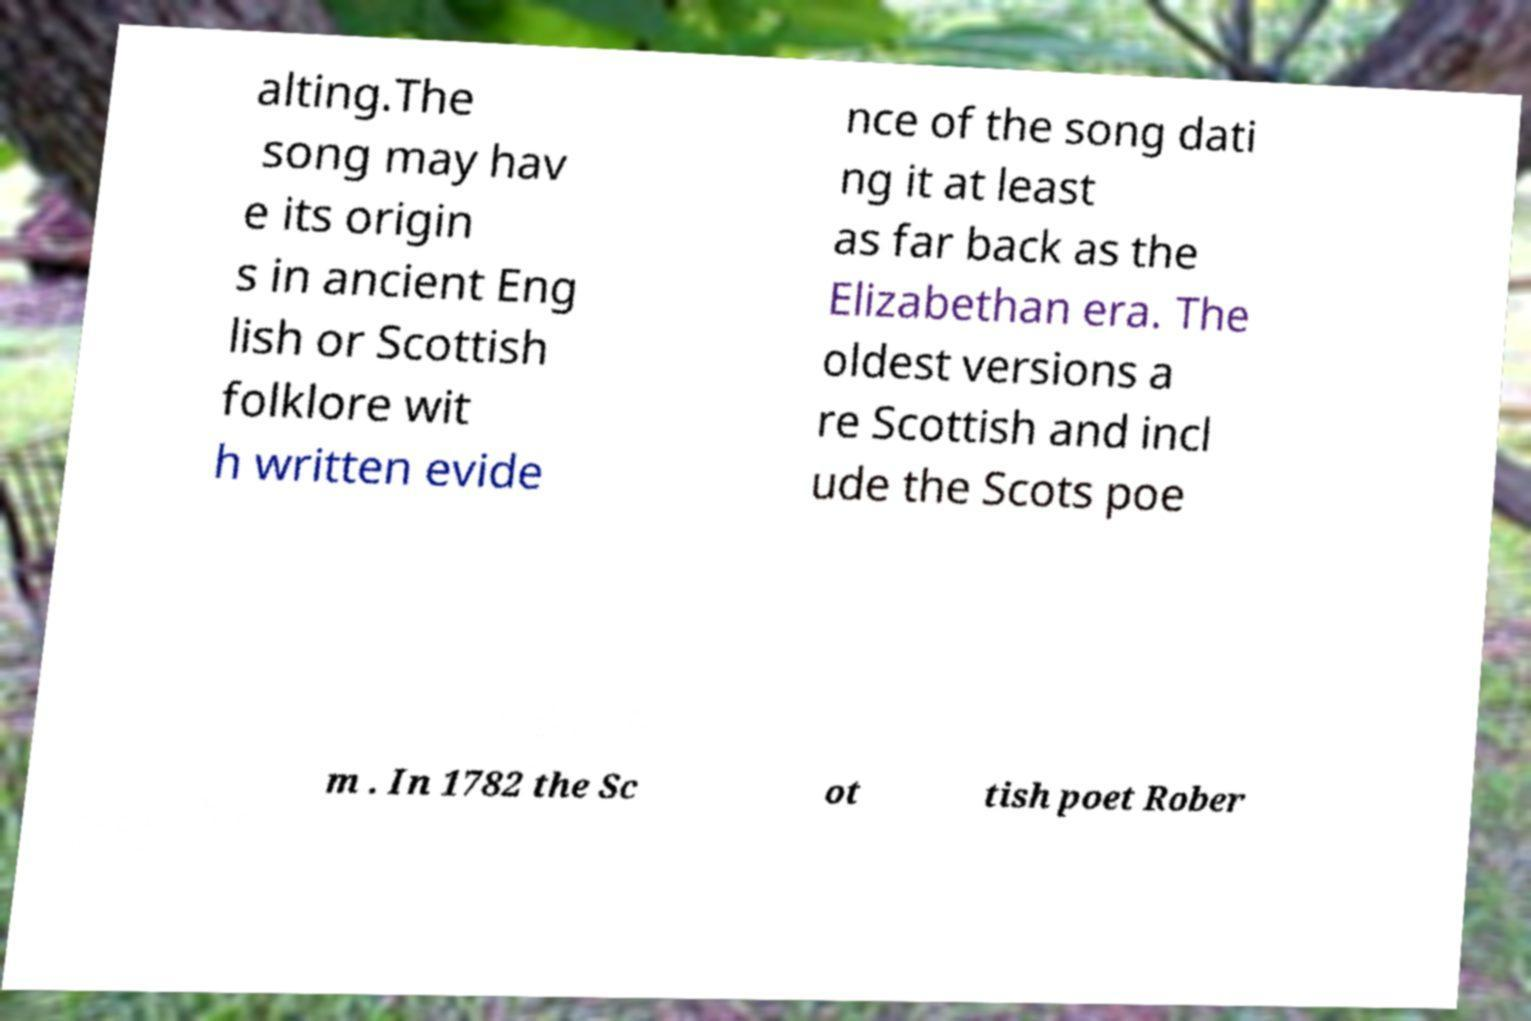For documentation purposes, I need the text within this image transcribed. Could you provide that? alting.The song may hav e its origin s in ancient Eng lish or Scottish folklore wit h written evide nce of the song dati ng it at least as far back as the Elizabethan era. The oldest versions a re Scottish and incl ude the Scots poe m . In 1782 the Sc ot tish poet Rober 